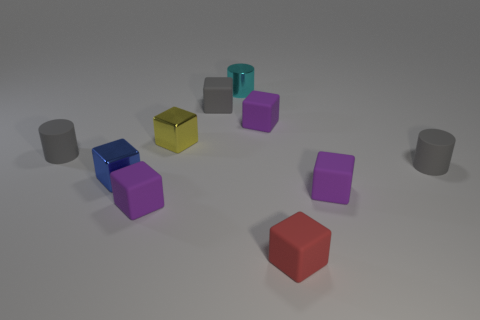Subtract all red cylinders. How many purple cubes are left? 3 Subtract all yellow blocks. How many blocks are left? 6 Subtract all small blue cubes. How many cubes are left? 6 Subtract all green blocks. Subtract all blue spheres. How many blocks are left? 7 Subtract all blocks. How many objects are left? 3 Add 4 small gray things. How many small gray things exist? 7 Subtract 3 purple cubes. How many objects are left? 7 Subtract all blue metal things. Subtract all tiny rubber cylinders. How many objects are left? 7 Add 7 tiny gray cylinders. How many tiny gray cylinders are left? 9 